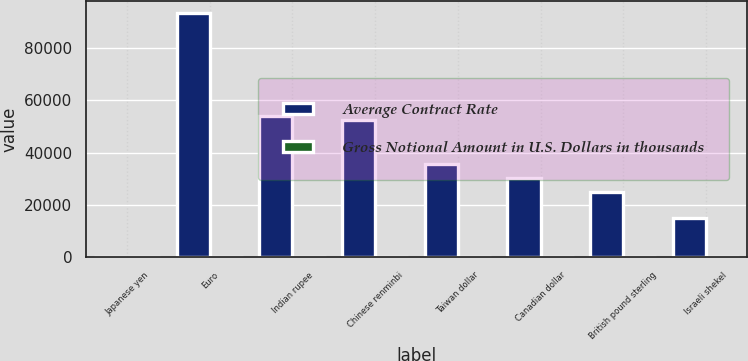Convert chart. <chart><loc_0><loc_0><loc_500><loc_500><stacked_bar_chart><ecel><fcel>Japanese yen<fcel>Euro<fcel>Indian rupee<fcel>Chinese renminbi<fcel>Taiwan dollar<fcel>Canadian dollar<fcel>British pound sterling<fcel>Israeli shekel<nl><fcel>Average Contract Rate<fcel>79.09<fcel>93316<fcel>54016<fcel>52669<fcel>35633<fcel>30180<fcel>24862<fcel>14982<nl><fcel>Gross Notional Amount in U.S. Dollars in thousands<fcel>79.09<fcel>0.76<fcel>54.44<fcel>6.35<fcel>29.17<fcel>1.01<fcel>0.63<fcel>4.01<nl></chart> 